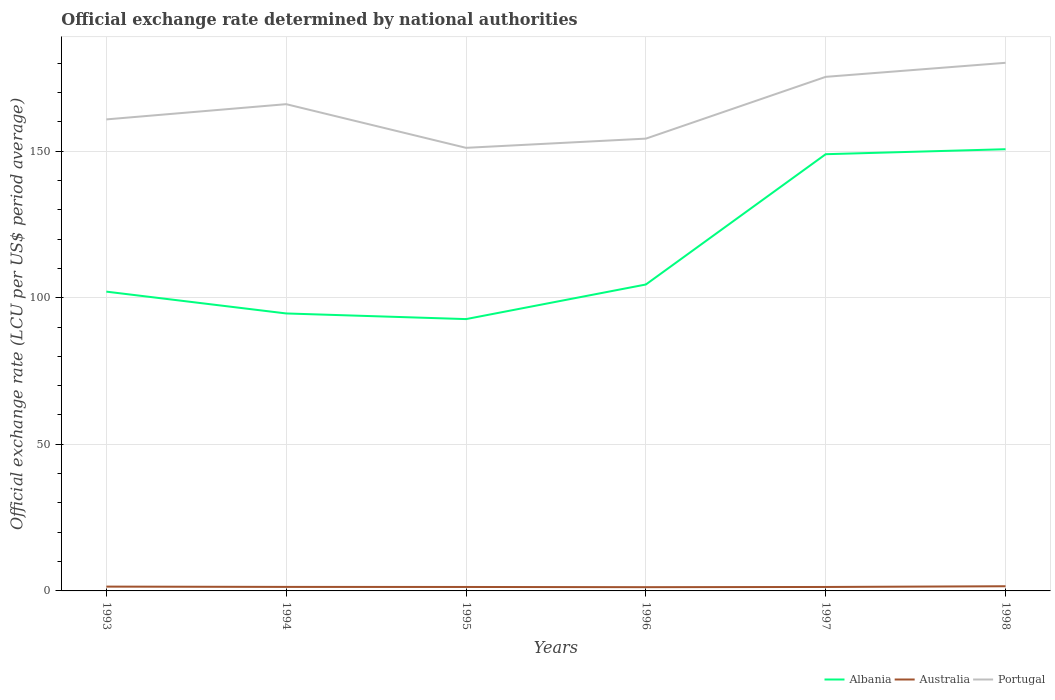Does the line corresponding to Australia intersect with the line corresponding to Portugal?
Your answer should be very brief. No. Across all years, what is the maximum official exchange rate in Portugal?
Give a very brief answer. 151.11. In which year was the official exchange rate in Portugal maximum?
Offer a very short reply. 1995. What is the total official exchange rate in Australia in the graph?
Keep it short and to the point. 0.07. What is the difference between the highest and the second highest official exchange rate in Portugal?
Your answer should be very brief. 29. Is the official exchange rate in Albania strictly greater than the official exchange rate in Portugal over the years?
Provide a short and direct response. Yes. What is the difference between two consecutive major ticks on the Y-axis?
Your answer should be compact. 50. Are the values on the major ticks of Y-axis written in scientific E-notation?
Ensure brevity in your answer.  No. Does the graph contain grids?
Give a very brief answer. Yes. Where does the legend appear in the graph?
Ensure brevity in your answer.  Bottom right. What is the title of the graph?
Provide a short and direct response. Official exchange rate determined by national authorities. What is the label or title of the Y-axis?
Provide a short and direct response. Official exchange rate (LCU per US$ period average). What is the Official exchange rate (LCU per US$ period average) of Albania in 1993?
Offer a very short reply. 102.06. What is the Official exchange rate (LCU per US$ period average) in Australia in 1993?
Make the answer very short. 1.47. What is the Official exchange rate (LCU per US$ period average) of Portugal in 1993?
Provide a short and direct response. 160.8. What is the Official exchange rate (LCU per US$ period average) in Albania in 1994?
Your answer should be very brief. 94.62. What is the Official exchange rate (LCU per US$ period average) of Australia in 1994?
Your answer should be compact. 1.37. What is the Official exchange rate (LCU per US$ period average) in Portugal in 1994?
Provide a succinct answer. 165.99. What is the Official exchange rate (LCU per US$ period average) in Albania in 1995?
Offer a terse response. 92.7. What is the Official exchange rate (LCU per US$ period average) of Australia in 1995?
Provide a succinct answer. 1.35. What is the Official exchange rate (LCU per US$ period average) of Portugal in 1995?
Your response must be concise. 151.11. What is the Official exchange rate (LCU per US$ period average) in Albania in 1996?
Keep it short and to the point. 104.5. What is the Official exchange rate (LCU per US$ period average) in Australia in 1996?
Make the answer very short. 1.28. What is the Official exchange rate (LCU per US$ period average) in Portugal in 1996?
Your response must be concise. 154.24. What is the Official exchange rate (LCU per US$ period average) of Albania in 1997?
Provide a succinct answer. 148.93. What is the Official exchange rate (LCU per US$ period average) in Australia in 1997?
Provide a short and direct response. 1.35. What is the Official exchange rate (LCU per US$ period average) of Portugal in 1997?
Provide a succinct answer. 175.31. What is the Official exchange rate (LCU per US$ period average) in Albania in 1998?
Give a very brief answer. 150.63. What is the Official exchange rate (LCU per US$ period average) in Australia in 1998?
Your answer should be compact. 1.59. What is the Official exchange rate (LCU per US$ period average) of Portugal in 1998?
Provide a succinct answer. 180.1. Across all years, what is the maximum Official exchange rate (LCU per US$ period average) in Albania?
Your answer should be very brief. 150.63. Across all years, what is the maximum Official exchange rate (LCU per US$ period average) of Australia?
Your answer should be compact. 1.59. Across all years, what is the maximum Official exchange rate (LCU per US$ period average) in Portugal?
Offer a very short reply. 180.1. Across all years, what is the minimum Official exchange rate (LCU per US$ period average) of Albania?
Offer a terse response. 92.7. Across all years, what is the minimum Official exchange rate (LCU per US$ period average) in Australia?
Keep it short and to the point. 1.28. Across all years, what is the minimum Official exchange rate (LCU per US$ period average) in Portugal?
Your answer should be very brief. 151.11. What is the total Official exchange rate (LCU per US$ period average) in Albania in the graph?
Make the answer very short. 693.45. What is the total Official exchange rate (LCU per US$ period average) of Australia in the graph?
Your response must be concise. 8.4. What is the total Official exchange rate (LCU per US$ period average) of Portugal in the graph?
Provide a succinct answer. 987.56. What is the difference between the Official exchange rate (LCU per US$ period average) in Albania in 1993 and that in 1994?
Your answer should be compact. 7.44. What is the difference between the Official exchange rate (LCU per US$ period average) of Australia in 1993 and that in 1994?
Ensure brevity in your answer.  0.1. What is the difference between the Official exchange rate (LCU per US$ period average) of Portugal in 1993 and that in 1994?
Give a very brief answer. -5.19. What is the difference between the Official exchange rate (LCU per US$ period average) of Albania in 1993 and that in 1995?
Your response must be concise. 9.37. What is the difference between the Official exchange rate (LCU per US$ period average) in Australia in 1993 and that in 1995?
Your answer should be very brief. 0.12. What is the difference between the Official exchange rate (LCU per US$ period average) in Portugal in 1993 and that in 1995?
Provide a succinct answer. 9.69. What is the difference between the Official exchange rate (LCU per US$ period average) in Albania in 1993 and that in 1996?
Make the answer very short. -2.44. What is the difference between the Official exchange rate (LCU per US$ period average) of Australia in 1993 and that in 1996?
Provide a short and direct response. 0.19. What is the difference between the Official exchange rate (LCU per US$ period average) of Portugal in 1993 and that in 1996?
Your answer should be very brief. 6.56. What is the difference between the Official exchange rate (LCU per US$ period average) of Albania in 1993 and that in 1997?
Ensure brevity in your answer.  -46.87. What is the difference between the Official exchange rate (LCU per US$ period average) of Australia in 1993 and that in 1997?
Provide a succinct answer. 0.12. What is the difference between the Official exchange rate (LCU per US$ period average) in Portugal in 1993 and that in 1997?
Make the answer very short. -14.51. What is the difference between the Official exchange rate (LCU per US$ period average) in Albania in 1993 and that in 1998?
Offer a terse response. -48.57. What is the difference between the Official exchange rate (LCU per US$ period average) of Australia in 1993 and that in 1998?
Ensure brevity in your answer.  -0.12. What is the difference between the Official exchange rate (LCU per US$ period average) of Portugal in 1993 and that in 1998?
Provide a short and direct response. -19.3. What is the difference between the Official exchange rate (LCU per US$ period average) of Albania in 1994 and that in 1995?
Provide a succinct answer. 1.93. What is the difference between the Official exchange rate (LCU per US$ period average) in Australia in 1994 and that in 1995?
Your answer should be compact. 0.02. What is the difference between the Official exchange rate (LCU per US$ period average) of Portugal in 1994 and that in 1995?
Keep it short and to the point. 14.89. What is the difference between the Official exchange rate (LCU per US$ period average) of Albania in 1994 and that in 1996?
Offer a terse response. -9.88. What is the difference between the Official exchange rate (LCU per US$ period average) of Australia in 1994 and that in 1996?
Provide a short and direct response. 0.09. What is the difference between the Official exchange rate (LCU per US$ period average) in Portugal in 1994 and that in 1996?
Offer a terse response. 11.75. What is the difference between the Official exchange rate (LCU per US$ period average) in Albania in 1994 and that in 1997?
Make the answer very short. -54.31. What is the difference between the Official exchange rate (LCU per US$ period average) in Australia in 1994 and that in 1997?
Ensure brevity in your answer.  0.02. What is the difference between the Official exchange rate (LCU per US$ period average) in Portugal in 1994 and that in 1997?
Ensure brevity in your answer.  -9.32. What is the difference between the Official exchange rate (LCU per US$ period average) in Albania in 1994 and that in 1998?
Your answer should be very brief. -56.01. What is the difference between the Official exchange rate (LCU per US$ period average) in Australia in 1994 and that in 1998?
Your answer should be very brief. -0.22. What is the difference between the Official exchange rate (LCU per US$ period average) of Portugal in 1994 and that in 1998?
Make the answer very short. -14.11. What is the difference between the Official exchange rate (LCU per US$ period average) of Albania in 1995 and that in 1996?
Provide a succinct answer. -11.8. What is the difference between the Official exchange rate (LCU per US$ period average) in Australia in 1995 and that in 1996?
Offer a very short reply. 0.07. What is the difference between the Official exchange rate (LCU per US$ period average) in Portugal in 1995 and that in 1996?
Your answer should be compact. -3.14. What is the difference between the Official exchange rate (LCU per US$ period average) in Albania in 1995 and that in 1997?
Your response must be concise. -56.24. What is the difference between the Official exchange rate (LCU per US$ period average) of Australia in 1995 and that in 1997?
Ensure brevity in your answer.  0. What is the difference between the Official exchange rate (LCU per US$ period average) in Portugal in 1995 and that in 1997?
Your answer should be compact. -24.21. What is the difference between the Official exchange rate (LCU per US$ period average) of Albania in 1995 and that in 1998?
Keep it short and to the point. -57.94. What is the difference between the Official exchange rate (LCU per US$ period average) in Australia in 1995 and that in 1998?
Offer a terse response. -0.24. What is the difference between the Official exchange rate (LCU per US$ period average) of Portugal in 1995 and that in 1998?
Your response must be concise. -29. What is the difference between the Official exchange rate (LCU per US$ period average) in Albania in 1996 and that in 1997?
Give a very brief answer. -44.43. What is the difference between the Official exchange rate (LCU per US$ period average) in Australia in 1996 and that in 1997?
Offer a very short reply. -0.07. What is the difference between the Official exchange rate (LCU per US$ period average) of Portugal in 1996 and that in 1997?
Offer a very short reply. -21.07. What is the difference between the Official exchange rate (LCU per US$ period average) of Albania in 1996 and that in 1998?
Provide a short and direct response. -46.13. What is the difference between the Official exchange rate (LCU per US$ period average) in Australia in 1996 and that in 1998?
Your answer should be compact. -0.31. What is the difference between the Official exchange rate (LCU per US$ period average) of Portugal in 1996 and that in 1998?
Make the answer very short. -25.86. What is the difference between the Official exchange rate (LCU per US$ period average) in Albania in 1997 and that in 1998?
Provide a short and direct response. -1.7. What is the difference between the Official exchange rate (LCU per US$ period average) of Australia in 1997 and that in 1998?
Your answer should be very brief. -0.24. What is the difference between the Official exchange rate (LCU per US$ period average) in Portugal in 1997 and that in 1998?
Make the answer very short. -4.79. What is the difference between the Official exchange rate (LCU per US$ period average) in Albania in 1993 and the Official exchange rate (LCU per US$ period average) in Australia in 1994?
Ensure brevity in your answer.  100.69. What is the difference between the Official exchange rate (LCU per US$ period average) in Albania in 1993 and the Official exchange rate (LCU per US$ period average) in Portugal in 1994?
Provide a succinct answer. -63.93. What is the difference between the Official exchange rate (LCU per US$ period average) of Australia in 1993 and the Official exchange rate (LCU per US$ period average) of Portugal in 1994?
Keep it short and to the point. -164.52. What is the difference between the Official exchange rate (LCU per US$ period average) in Albania in 1993 and the Official exchange rate (LCU per US$ period average) in Australia in 1995?
Provide a succinct answer. 100.71. What is the difference between the Official exchange rate (LCU per US$ period average) in Albania in 1993 and the Official exchange rate (LCU per US$ period average) in Portugal in 1995?
Your response must be concise. -49.04. What is the difference between the Official exchange rate (LCU per US$ period average) of Australia in 1993 and the Official exchange rate (LCU per US$ period average) of Portugal in 1995?
Your response must be concise. -149.63. What is the difference between the Official exchange rate (LCU per US$ period average) in Albania in 1993 and the Official exchange rate (LCU per US$ period average) in Australia in 1996?
Your answer should be compact. 100.78. What is the difference between the Official exchange rate (LCU per US$ period average) in Albania in 1993 and the Official exchange rate (LCU per US$ period average) in Portugal in 1996?
Your response must be concise. -52.18. What is the difference between the Official exchange rate (LCU per US$ period average) of Australia in 1993 and the Official exchange rate (LCU per US$ period average) of Portugal in 1996?
Keep it short and to the point. -152.77. What is the difference between the Official exchange rate (LCU per US$ period average) of Albania in 1993 and the Official exchange rate (LCU per US$ period average) of Australia in 1997?
Your response must be concise. 100.72. What is the difference between the Official exchange rate (LCU per US$ period average) in Albania in 1993 and the Official exchange rate (LCU per US$ period average) in Portugal in 1997?
Give a very brief answer. -73.25. What is the difference between the Official exchange rate (LCU per US$ period average) in Australia in 1993 and the Official exchange rate (LCU per US$ period average) in Portugal in 1997?
Make the answer very short. -173.84. What is the difference between the Official exchange rate (LCU per US$ period average) of Albania in 1993 and the Official exchange rate (LCU per US$ period average) of Australia in 1998?
Your answer should be very brief. 100.47. What is the difference between the Official exchange rate (LCU per US$ period average) in Albania in 1993 and the Official exchange rate (LCU per US$ period average) in Portugal in 1998?
Your answer should be very brief. -78.04. What is the difference between the Official exchange rate (LCU per US$ period average) in Australia in 1993 and the Official exchange rate (LCU per US$ period average) in Portugal in 1998?
Provide a short and direct response. -178.63. What is the difference between the Official exchange rate (LCU per US$ period average) in Albania in 1994 and the Official exchange rate (LCU per US$ period average) in Australia in 1995?
Ensure brevity in your answer.  93.27. What is the difference between the Official exchange rate (LCU per US$ period average) in Albania in 1994 and the Official exchange rate (LCU per US$ period average) in Portugal in 1995?
Your response must be concise. -56.48. What is the difference between the Official exchange rate (LCU per US$ period average) in Australia in 1994 and the Official exchange rate (LCU per US$ period average) in Portugal in 1995?
Your response must be concise. -149.74. What is the difference between the Official exchange rate (LCU per US$ period average) of Albania in 1994 and the Official exchange rate (LCU per US$ period average) of Australia in 1996?
Your answer should be compact. 93.35. What is the difference between the Official exchange rate (LCU per US$ period average) in Albania in 1994 and the Official exchange rate (LCU per US$ period average) in Portugal in 1996?
Give a very brief answer. -59.62. What is the difference between the Official exchange rate (LCU per US$ period average) in Australia in 1994 and the Official exchange rate (LCU per US$ period average) in Portugal in 1996?
Offer a very short reply. -152.88. What is the difference between the Official exchange rate (LCU per US$ period average) in Albania in 1994 and the Official exchange rate (LCU per US$ period average) in Australia in 1997?
Your answer should be very brief. 93.28. What is the difference between the Official exchange rate (LCU per US$ period average) in Albania in 1994 and the Official exchange rate (LCU per US$ period average) in Portugal in 1997?
Your answer should be very brief. -80.69. What is the difference between the Official exchange rate (LCU per US$ period average) in Australia in 1994 and the Official exchange rate (LCU per US$ period average) in Portugal in 1997?
Offer a very short reply. -173.94. What is the difference between the Official exchange rate (LCU per US$ period average) in Albania in 1994 and the Official exchange rate (LCU per US$ period average) in Australia in 1998?
Keep it short and to the point. 93.03. What is the difference between the Official exchange rate (LCU per US$ period average) in Albania in 1994 and the Official exchange rate (LCU per US$ period average) in Portugal in 1998?
Give a very brief answer. -85.48. What is the difference between the Official exchange rate (LCU per US$ period average) of Australia in 1994 and the Official exchange rate (LCU per US$ period average) of Portugal in 1998?
Keep it short and to the point. -178.74. What is the difference between the Official exchange rate (LCU per US$ period average) of Albania in 1995 and the Official exchange rate (LCU per US$ period average) of Australia in 1996?
Provide a succinct answer. 91.42. What is the difference between the Official exchange rate (LCU per US$ period average) of Albania in 1995 and the Official exchange rate (LCU per US$ period average) of Portugal in 1996?
Provide a succinct answer. -61.55. What is the difference between the Official exchange rate (LCU per US$ period average) in Australia in 1995 and the Official exchange rate (LCU per US$ period average) in Portugal in 1996?
Offer a very short reply. -152.89. What is the difference between the Official exchange rate (LCU per US$ period average) of Albania in 1995 and the Official exchange rate (LCU per US$ period average) of Australia in 1997?
Offer a terse response. 91.35. What is the difference between the Official exchange rate (LCU per US$ period average) in Albania in 1995 and the Official exchange rate (LCU per US$ period average) in Portugal in 1997?
Your answer should be very brief. -82.61. What is the difference between the Official exchange rate (LCU per US$ period average) in Australia in 1995 and the Official exchange rate (LCU per US$ period average) in Portugal in 1997?
Provide a short and direct response. -173.96. What is the difference between the Official exchange rate (LCU per US$ period average) of Albania in 1995 and the Official exchange rate (LCU per US$ period average) of Australia in 1998?
Give a very brief answer. 91.11. What is the difference between the Official exchange rate (LCU per US$ period average) of Albania in 1995 and the Official exchange rate (LCU per US$ period average) of Portugal in 1998?
Your answer should be very brief. -87.41. What is the difference between the Official exchange rate (LCU per US$ period average) of Australia in 1995 and the Official exchange rate (LCU per US$ period average) of Portugal in 1998?
Keep it short and to the point. -178.76. What is the difference between the Official exchange rate (LCU per US$ period average) of Albania in 1996 and the Official exchange rate (LCU per US$ period average) of Australia in 1997?
Give a very brief answer. 103.15. What is the difference between the Official exchange rate (LCU per US$ period average) in Albania in 1996 and the Official exchange rate (LCU per US$ period average) in Portugal in 1997?
Your answer should be very brief. -70.81. What is the difference between the Official exchange rate (LCU per US$ period average) of Australia in 1996 and the Official exchange rate (LCU per US$ period average) of Portugal in 1997?
Give a very brief answer. -174.03. What is the difference between the Official exchange rate (LCU per US$ period average) in Albania in 1996 and the Official exchange rate (LCU per US$ period average) in Australia in 1998?
Your response must be concise. 102.91. What is the difference between the Official exchange rate (LCU per US$ period average) of Albania in 1996 and the Official exchange rate (LCU per US$ period average) of Portugal in 1998?
Provide a short and direct response. -75.61. What is the difference between the Official exchange rate (LCU per US$ period average) of Australia in 1996 and the Official exchange rate (LCU per US$ period average) of Portugal in 1998?
Offer a terse response. -178.83. What is the difference between the Official exchange rate (LCU per US$ period average) in Albania in 1997 and the Official exchange rate (LCU per US$ period average) in Australia in 1998?
Your response must be concise. 147.34. What is the difference between the Official exchange rate (LCU per US$ period average) of Albania in 1997 and the Official exchange rate (LCU per US$ period average) of Portugal in 1998?
Ensure brevity in your answer.  -31.17. What is the difference between the Official exchange rate (LCU per US$ period average) of Australia in 1997 and the Official exchange rate (LCU per US$ period average) of Portugal in 1998?
Keep it short and to the point. -178.76. What is the average Official exchange rate (LCU per US$ period average) in Albania per year?
Make the answer very short. 115.57. What is the average Official exchange rate (LCU per US$ period average) in Australia per year?
Offer a very short reply. 1.4. What is the average Official exchange rate (LCU per US$ period average) in Portugal per year?
Your answer should be compact. 164.59. In the year 1993, what is the difference between the Official exchange rate (LCU per US$ period average) of Albania and Official exchange rate (LCU per US$ period average) of Australia?
Give a very brief answer. 100.59. In the year 1993, what is the difference between the Official exchange rate (LCU per US$ period average) in Albania and Official exchange rate (LCU per US$ period average) in Portugal?
Offer a terse response. -58.74. In the year 1993, what is the difference between the Official exchange rate (LCU per US$ period average) of Australia and Official exchange rate (LCU per US$ period average) of Portugal?
Make the answer very short. -159.33. In the year 1994, what is the difference between the Official exchange rate (LCU per US$ period average) of Albania and Official exchange rate (LCU per US$ period average) of Australia?
Ensure brevity in your answer.  93.26. In the year 1994, what is the difference between the Official exchange rate (LCU per US$ period average) of Albania and Official exchange rate (LCU per US$ period average) of Portugal?
Provide a succinct answer. -71.37. In the year 1994, what is the difference between the Official exchange rate (LCU per US$ period average) in Australia and Official exchange rate (LCU per US$ period average) in Portugal?
Your response must be concise. -164.62. In the year 1995, what is the difference between the Official exchange rate (LCU per US$ period average) of Albania and Official exchange rate (LCU per US$ period average) of Australia?
Keep it short and to the point. 91.35. In the year 1995, what is the difference between the Official exchange rate (LCU per US$ period average) in Albania and Official exchange rate (LCU per US$ period average) in Portugal?
Ensure brevity in your answer.  -58.41. In the year 1995, what is the difference between the Official exchange rate (LCU per US$ period average) of Australia and Official exchange rate (LCU per US$ period average) of Portugal?
Ensure brevity in your answer.  -149.76. In the year 1996, what is the difference between the Official exchange rate (LCU per US$ period average) in Albania and Official exchange rate (LCU per US$ period average) in Australia?
Provide a succinct answer. 103.22. In the year 1996, what is the difference between the Official exchange rate (LCU per US$ period average) of Albania and Official exchange rate (LCU per US$ period average) of Portugal?
Offer a very short reply. -49.74. In the year 1996, what is the difference between the Official exchange rate (LCU per US$ period average) in Australia and Official exchange rate (LCU per US$ period average) in Portugal?
Offer a very short reply. -152.97. In the year 1997, what is the difference between the Official exchange rate (LCU per US$ period average) of Albania and Official exchange rate (LCU per US$ period average) of Australia?
Your answer should be very brief. 147.59. In the year 1997, what is the difference between the Official exchange rate (LCU per US$ period average) in Albania and Official exchange rate (LCU per US$ period average) in Portugal?
Make the answer very short. -26.38. In the year 1997, what is the difference between the Official exchange rate (LCU per US$ period average) of Australia and Official exchange rate (LCU per US$ period average) of Portugal?
Keep it short and to the point. -173.97. In the year 1998, what is the difference between the Official exchange rate (LCU per US$ period average) in Albania and Official exchange rate (LCU per US$ period average) in Australia?
Offer a terse response. 149.04. In the year 1998, what is the difference between the Official exchange rate (LCU per US$ period average) of Albania and Official exchange rate (LCU per US$ period average) of Portugal?
Offer a terse response. -29.47. In the year 1998, what is the difference between the Official exchange rate (LCU per US$ period average) of Australia and Official exchange rate (LCU per US$ period average) of Portugal?
Your answer should be compact. -178.51. What is the ratio of the Official exchange rate (LCU per US$ period average) of Albania in 1993 to that in 1994?
Ensure brevity in your answer.  1.08. What is the ratio of the Official exchange rate (LCU per US$ period average) of Australia in 1993 to that in 1994?
Make the answer very short. 1.08. What is the ratio of the Official exchange rate (LCU per US$ period average) in Portugal in 1993 to that in 1994?
Your response must be concise. 0.97. What is the ratio of the Official exchange rate (LCU per US$ period average) of Albania in 1993 to that in 1995?
Your answer should be very brief. 1.1. What is the ratio of the Official exchange rate (LCU per US$ period average) of Australia in 1993 to that in 1995?
Provide a succinct answer. 1.09. What is the ratio of the Official exchange rate (LCU per US$ period average) of Portugal in 1993 to that in 1995?
Ensure brevity in your answer.  1.06. What is the ratio of the Official exchange rate (LCU per US$ period average) of Albania in 1993 to that in 1996?
Your answer should be compact. 0.98. What is the ratio of the Official exchange rate (LCU per US$ period average) of Australia in 1993 to that in 1996?
Provide a short and direct response. 1.15. What is the ratio of the Official exchange rate (LCU per US$ period average) in Portugal in 1993 to that in 1996?
Make the answer very short. 1.04. What is the ratio of the Official exchange rate (LCU per US$ period average) of Albania in 1993 to that in 1997?
Make the answer very short. 0.69. What is the ratio of the Official exchange rate (LCU per US$ period average) in Australia in 1993 to that in 1997?
Your response must be concise. 1.09. What is the ratio of the Official exchange rate (LCU per US$ period average) of Portugal in 1993 to that in 1997?
Your answer should be compact. 0.92. What is the ratio of the Official exchange rate (LCU per US$ period average) of Albania in 1993 to that in 1998?
Provide a short and direct response. 0.68. What is the ratio of the Official exchange rate (LCU per US$ period average) in Australia in 1993 to that in 1998?
Your response must be concise. 0.92. What is the ratio of the Official exchange rate (LCU per US$ period average) of Portugal in 1993 to that in 1998?
Make the answer very short. 0.89. What is the ratio of the Official exchange rate (LCU per US$ period average) in Albania in 1994 to that in 1995?
Your response must be concise. 1.02. What is the ratio of the Official exchange rate (LCU per US$ period average) in Australia in 1994 to that in 1995?
Make the answer very short. 1.01. What is the ratio of the Official exchange rate (LCU per US$ period average) of Portugal in 1994 to that in 1995?
Give a very brief answer. 1.1. What is the ratio of the Official exchange rate (LCU per US$ period average) in Albania in 1994 to that in 1996?
Your response must be concise. 0.91. What is the ratio of the Official exchange rate (LCU per US$ period average) in Australia in 1994 to that in 1996?
Offer a terse response. 1.07. What is the ratio of the Official exchange rate (LCU per US$ period average) in Portugal in 1994 to that in 1996?
Your response must be concise. 1.08. What is the ratio of the Official exchange rate (LCU per US$ period average) of Albania in 1994 to that in 1997?
Your response must be concise. 0.64. What is the ratio of the Official exchange rate (LCU per US$ period average) in Australia in 1994 to that in 1997?
Provide a short and direct response. 1.02. What is the ratio of the Official exchange rate (LCU per US$ period average) in Portugal in 1994 to that in 1997?
Offer a terse response. 0.95. What is the ratio of the Official exchange rate (LCU per US$ period average) in Albania in 1994 to that in 1998?
Offer a very short reply. 0.63. What is the ratio of the Official exchange rate (LCU per US$ period average) of Australia in 1994 to that in 1998?
Offer a very short reply. 0.86. What is the ratio of the Official exchange rate (LCU per US$ period average) of Portugal in 1994 to that in 1998?
Offer a terse response. 0.92. What is the ratio of the Official exchange rate (LCU per US$ period average) in Albania in 1995 to that in 1996?
Make the answer very short. 0.89. What is the ratio of the Official exchange rate (LCU per US$ period average) of Australia in 1995 to that in 1996?
Ensure brevity in your answer.  1.06. What is the ratio of the Official exchange rate (LCU per US$ period average) in Portugal in 1995 to that in 1996?
Your answer should be compact. 0.98. What is the ratio of the Official exchange rate (LCU per US$ period average) in Albania in 1995 to that in 1997?
Provide a succinct answer. 0.62. What is the ratio of the Official exchange rate (LCU per US$ period average) in Australia in 1995 to that in 1997?
Offer a very short reply. 1. What is the ratio of the Official exchange rate (LCU per US$ period average) of Portugal in 1995 to that in 1997?
Your answer should be compact. 0.86. What is the ratio of the Official exchange rate (LCU per US$ period average) in Albania in 1995 to that in 1998?
Your response must be concise. 0.62. What is the ratio of the Official exchange rate (LCU per US$ period average) in Australia in 1995 to that in 1998?
Your answer should be very brief. 0.85. What is the ratio of the Official exchange rate (LCU per US$ period average) of Portugal in 1995 to that in 1998?
Provide a succinct answer. 0.84. What is the ratio of the Official exchange rate (LCU per US$ period average) of Albania in 1996 to that in 1997?
Keep it short and to the point. 0.7. What is the ratio of the Official exchange rate (LCU per US$ period average) of Australia in 1996 to that in 1997?
Your answer should be very brief. 0.95. What is the ratio of the Official exchange rate (LCU per US$ period average) of Portugal in 1996 to that in 1997?
Provide a short and direct response. 0.88. What is the ratio of the Official exchange rate (LCU per US$ period average) in Albania in 1996 to that in 1998?
Keep it short and to the point. 0.69. What is the ratio of the Official exchange rate (LCU per US$ period average) of Australia in 1996 to that in 1998?
Your response must be concise. 0.8. What is the ratio of the Official exchange rate (LCU per US$ period average) in Portugal in 1996 to that in 1998?
Your answer should be very brief. 0.86. What is the ratio of the Official exchange rate (LCU per US$ period average) of Albania in 1997 to that in 1998?
Provide a succinct answer. 0.99. What is the ratio of the Official exchange rate (LCU per US$ period average) of Australia in 1997 to that in 1998?
Give a very brief answer. 0.85. What is the ratio of the Official exchange rate (LCU per US$ period average) in Portugal in 1997 to that in 1998?
Your answer should be very brief. 0.97. What is the difference between the highest and the second highest Official exchange rate (LCU per US$ period average) of Albania?
Provide a short and direct response. 1.7. What is the difference between the highest and the second highest Official exchange rate (LCU per US$ period average) in Australia?
Provide a short and direct response. 0.12. What is the difference between the highest and the second highest Official exchange rate (LCU per US$ period average) of Portugal?
Give a very brief answer. 4.79. What is the difference between the highest and the lowest Official exchange rate (LCU per US$ period average) of Albania?
Your response must be concise. 57.94. What is the difference between the highest and the lowest Official exchange rate (LCU per US$ period average) in Australia?
Give a very brief answer. 0.31. What is the difference between the highest and the lowest Official exchange rate (LCU per US$ period average) of Portugal?
Provide a short and direct response. 29. 